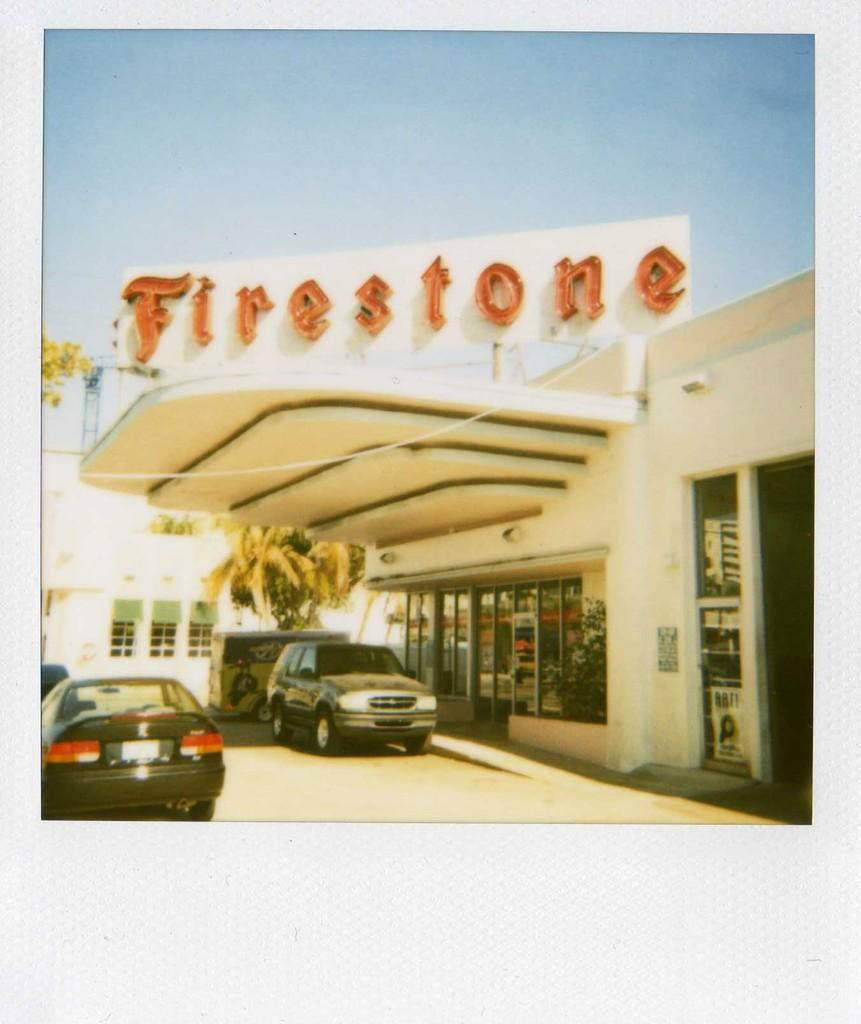What type of vehicles can be seen on the road in the image? There are cars on the road in the image. What natural elements are visible in the image? There are visible in the image. What type of structures can be seen in the image? There are buildings with windows in the image. What is visible in the background of the image? The sky is visible in the background of the image. What type of camera can be seen in the image? There is no camera present in the image. What body part can be seen on the trees in the image? Trees do not have body parts, so this question is not applicable. 